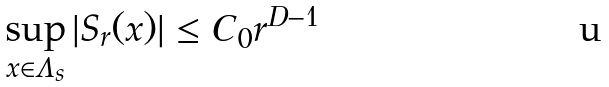Convert formula to latex. <formula><loc_0><loc_0><loc_500><loc_500>\sup _ { x \in \Lambda _ { s } } | S _ { r } ( x ) | \leq C _ { 0 } r ^ { D - 1 }</formula> 